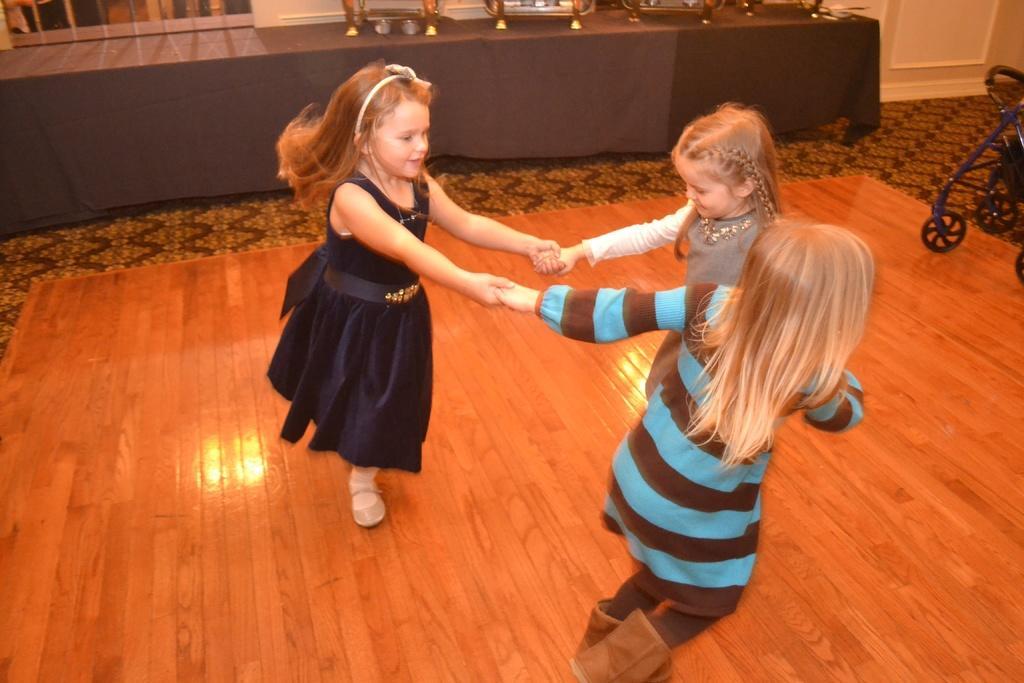How would you summarize this image in a sentence or two? This image is taken indoors. At the bottom of the image there is a floor. In the background there is a wall with a door and a window. There is a table with a tablecloth and a few things on it. On the right side of the image there is an object on the floor. In the middle of the image three kids are playing and they are holding each others hands. 